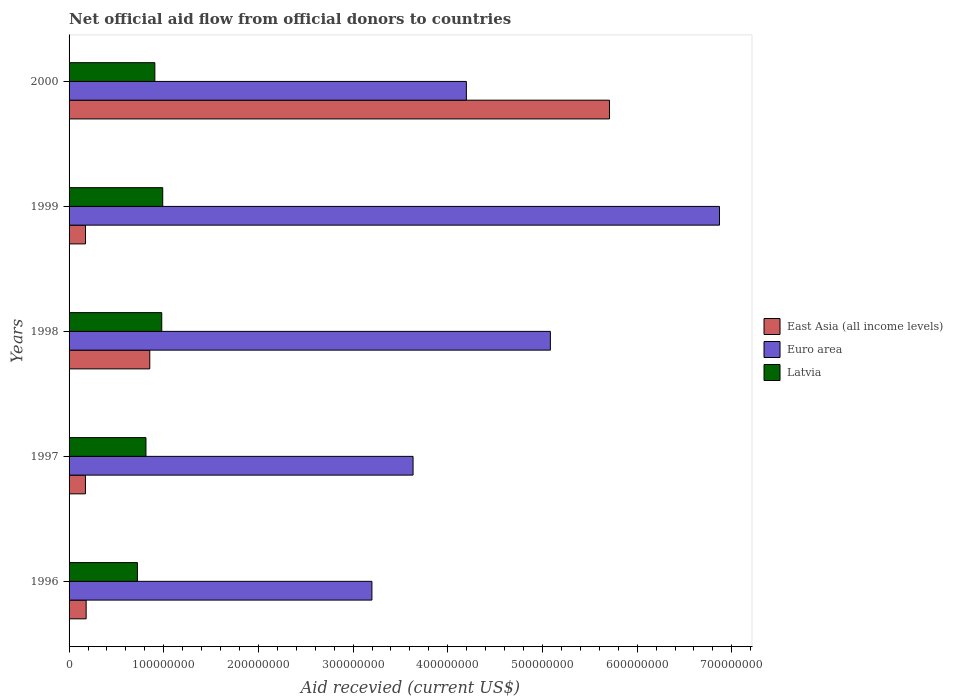Are the number of bars per tick equal to the number of legend labels?
Ensure brevity in your answer.  Yes. What is the label of the 5th group of bars from the top?
Your response must be concise. 1996. In how many cases, is the number of bars for a given year not equal to the number of legend labels?
Ensure brevity in your answer.  0. What is the total aid received in Latvia in 1996?
Your answer should be very brief. 7.22e+07. Across all years, what is the maximum total aid received in Latvia?
Keep it short and to the point. 9.89e+07. Across all years, what is the minimum total aid received in East Asia (all income levels)?
Give a very brief answer. 1.73e+07. In which year was the total aid received in Euro area minimum?
Your answer should be very brief. 1996. What is the total total aid received in Latvia in the graph?
Ensure brevity in your answer.  4.41e+08. What is the difference between the total aid received in Euro area in 1997 and that in 1998?
Your answer should be compact. -1.45e+08. What is the difference between the total aid received in Euro area in 1998 and the total aid received in East Asia (all income levels) in 1999?
Provide a succinct answer. 4.91e+08. What is the average total aid received in Latvia per year?
Offer a very short reply. 8.82e+07. In the year 1999, what is the difference between the total aid received in East Asia (all income levels) and total aid received in Latvia?
Your answer should be compact. -8.16e+07. In how many years, is the total aid received in Euro area greater than 640000000 US$?
Your answer should be very brief. 1. What is the ratio of the total aid received in Euro area in 1998 to that in 1999?
Offer a very short reply. 0.74. Is the total aid received in Euro area in 1996 less than that in 2000?
Provide a succinct answer. Yes. Is the difference between the total aid received in East Asia (all income levels) in 1999 and 2000 greater than the difference between the total aid received in Latvia in 1999 and 2000?
Provide a succinct answer. No. What is the difference between the highest and the second highest total aid received in East Asia (all income levels)?
Provide a succinct answer. 4.86e+08. What is the difference between the highest and the lowest total aid received in East Asia (all income levels)?
Your response must be concise. 5.54e+08. In how many years, is the total aid received in East Asia (all income levels) greater than the average total aid received in East Asia (all income levels) taken over all years?
Ensure brevity in your answer.  1. What does the 2nd bar from the bottom in 2000 represents?
Give a very brief answer. Euro area. Is it the case that in every year, the sum of the total aid received in East Asia (all income levels) and total aid received in Latvia is greater than the total aid received in Euro area?
Your answer should be very brief. No. Are all the bars in the graph horizontal?
Provide a short and direct response. Yes. How many years are there in the graph?
Your answer should be compact. 5. Does the graph contain any zero values?
Ensure brevity in your answer.  No. Where does the legend appear in the graph?
Offer a very short reply. Center right. How many legend labels are there?
Ensure brevity in your answer.  3. What is the title of the graph?
Offer a very short reply. Net official aid flow from official donors to countries. Does "Bosnia and Herzegovina" appear as one of the legend labels in the graph?
Your response must be concise. No. What is the label or title of the X-axis?
Provide a succinct answer. Aid recevied (current US$). What is the label or title of the Y-axis?
Provide a succinct answer. Years. What is the Aid recevied (current US$) in East Asia (all income levels) in 1996?
Your answer should be very brief. 1.80e+07. What is the Aid recevied (current US$) of Euro area in 1996?
Your response must be concise. 3.20e+08. What is the Aid recevied (current US$) of Latvia in 1996?
Your answer should be compact. 7.22e+07. What is the Aid recevied (current US$) of East Asia (all income levels) in 1997?
Provide a short and direct response. 1.73e+07. What is the Aid recevied (current US$) of Euro area in 1997?
Provide a short and direct response. 3.63e+08. What is the Aid recevied (current US$) of Latvia in 1997?
Provide a short and direct response. 8.12e+07. What is the Aid recevied (current US$) of East Asia (all income levels) in 1998?
Offer a very short reply. 8.52e+07. What is the Aid recevied (current US$) in Euro area in 1998?
Keep it short and to the point. 5.08e+08. What is the Aid recevied (current US$) in Latvia in 1998?
Provide a succinct answer. 9.79e+07. What is the Aid recevied (current US$) in East Asia (all income levels) in 1999?
Give a very brief answer. 1.74e+07. What is the Aid recevied (current US$) in Euro area in 1999?
Ensure brevity in your answer.  6.87e+08. What is the Aid recevied (current US$) of Latvia in 1999?
Offer a terse response. 9.89e+07. What is the Aid recevied (current US$) in East Asia (all income levels) in 2000?
Your answer should be compact. 5.71e+08. What is the Aid recevied (current US$) of Euro area in 2000?
Your answer should be compact. 4.20e+08. What is the Aid recevied (current US$) of Latvia in 2000?
Provide a short and direct response. 9.06e+07. Across all years, what is the maximum Aid recevied (current US$) in East Asia (all income levels)?
Your response must be concise. 5.71e+08. Across all years, what is the maximum Aid recevied (current US$) of Euro area?
Your answer should be very brief. 6.87e+08. Across all years, what is the maximum Aid recevied (current US$) of Latvia?
Keep it short and to the point. 9.89e+07. Across all years, what is the minimum Aid recevied (current US$) of East Asia (all income levels)?
Your answer should be compact. 1.73e+07. Across all years, what is the minimum Aid recevied (current US$) in Euro area?
Offer a terse response. 3.20e+08. Across all years, what is the minimum Aid recevied (current US$) of Latvia?
Offer a terse response. 7.22e+07. What is the total Aid recevied (current US$) of East Asia (all income levels) in the graph?
Provide a short and direct response. 7.09e+08. What is the total Aid recevied (current US$) of Euro area in the graph?
Make the answer very short. 2.30e+09. What is the total Aid recevied (current US$) in Latvia in the graph?
Provide a short and direct response. 4.41e+08. What is the difference between the Aid recevied (current US$) of East Asia (all income levels) in 1996 and that in 1997?
Keep it short and to the point. 7.60e+05. What is the difference between the Aid recevied (current US$) in Euro area in 1996 and that in 1997?
Offer a terse response. -4.35e+07. What is the difference between the Aid recevied (current US$) of Latvia in 1996 and that in 1997?
Your answer should be compact. -9.01e+06. What is the difference between the Aid recevied (current US$) in East Asia (all income levels) in 1996 and that in 1998?
Ensure brevity in your answer.  -6.72e+07. What is the difference between the Aid recevied (current US$) of Euro area in 1996 and that in 1998?
Offer a very short reply. -1.88e+08. What is the difference between the Aid recevied (current US$) in Latvia in 1996 and that in 1998?
Make the answer very short. -2.57e+07. What is the difference between the Aid recevied (current US$) of East Asia (all income levels) in 1996 and that in 1999?
Make the answer very short. 7.00e+05. What is the difference between the Aid recevied (current US$) in Euro area in 1996 and that in 1999?
Provide a short and direct response. -3.67e+08. What is the difference between the Aid recevied (current US$) in Latvia in 1996 and that in 1999?
Your response must be concise. -2.67e+07. What is the difference between the Aid recevied (current US$) in East Asia (all income levels) in 1996 and that in 2000?
Offer a very short reply. -5.53e+08. What is the difference between the Aid recevied (current US$) of Euro area in 1996 and that in 2000?
Your response must be concise. -9.98e+07. What is the difference between the Aid recevied (current US$) of Latvia in 1996 and that in 2000?
Your answer should be compact. -1.84e+07. What is the difference between the Aid recevied (current US$) of East Asia (all income levels) in 1997 and that in 1998?
Your answer should be very brief. -6.80e+07. What is the difference between the Aid recevied (current US$) in Euro area in 1997 and that in 1998?
Make the answer very short. -1.45e+08. What is the difference between the Aid recevied (current US$) in Latvia in 1997 and that in 1998?
Your answer should be compact. -1.67e+07. What is the difference between the Aid recevied (current US$) of Euro area in 1997 and that in 1999?
Ensure brevity in your answer.  -3.24e+08. What is the difference between the Aid recevied (current US$) in Latvia in 1997 and that in 1999?
Your response must be concise. -1.77e+07. What is the difference between the Aid recevied (current US$) of East Asia (all income levels) in 1997 and that in 2000?
Make the answer very short. -5.54e+08. What is the difference between the Aid recevied (current US$) of Euro area in 1997 and that in 2000?
Your answer should be very brief. -5.63e+07. What is the difference between the Aid recevied (current US$) in Latvia in 1997 and that in 2000?
Your answer should be very brief. -9.39e+06. What is the difference between the Aid recevied (current US$) of East Asia (all income levels) in 1998 and that in 1999?
Offer a very short reply. 6.79e+07. What is the difference between the Aid recevied (current US$) of Euro area in 1998 and that in 1999?
Provide a succinct answer. -1.79e+08. What is the difference between the Aid recevied (current US$) in Latvia in 1998 and that in 1999?
Provide a short and direct response. -1.04e+06. What is the difference between the Aid recevied (current US$) in East Asia (all income levels) in 1998 and that in 2000?
Keep it short and to the point. -4.86e+08. What is the difference between the Aid recevied (current US$) of Euro area in 1998 and that in 2000?
Make the answer very short. 8.87e+07. What is the difference between the Aid recevied (current US$) in Latvia in 1998 and that in 2000?
Provide a short and direct response. 7.30e+06. What is the difference between the Aid recevied (current US$) in East Asia (all income levels) in 1999 and that in 2000?
Your answer should be compact. -5.53e+08. What is the difference between the Aid recevied (current US$) in Euro area in 1999 and that in 2000?
Offer a very short reply. 2.67e+08. What is the difference between the Aid recevied (current US$) in Latvia in 1999 and that in 2000?
Your answer should be compact. 8.34e+06. What is the difference between the Aid recevied (current US$) in East Asia (all income levels) in 1996 and the Aid recevied (current US$) in Euro area in 1997?
Provide a succinct answer. -3.45e+08. What is the difference between the Aid recevied (current US$) of East Asia (all income levels) in 1996 and the Aid recevied (current US$) of Latvia in 1997?
Offer a very short reply. -6.32e+07. What is the difference between the Aid recevied (current US$) in Euro area in 1996 and the Aid recevied (current US$) in Latvia in 1997?
Give a very brief answer. 2.39e+08. What is the difference between the Aid recevied (current US$) of East Asia (all income levels) in 1996 and the Aid recevied (current US$) of Euro area in 1998?
Your answer should be compact. -4.90e+08. What is the difference between the Aid recevied (current US$) in East Asia (all income levels) in 1996 and the Aid recevied (current US$) in Latvia in 1998?
Provide a short and direct response. -7.98e+07. What is the difference between the Aid recevied (current US$) in Euro area in 1996 and the Aid recevied (current US$) in Latvia in 1998?
Your answer should be compact. 2.22e+08. What is the difference between the Aid recevied (current US$) of East Asia (all income levels) in 1996 and the Aid recevied (current US$) of Euro area in 1999?
Your answer should be very brief. -6.69e+08. What is the difference between the Aid recevied (current US$) in East Asia (all income levels) in 1996 and the Aid recevied (current US$) in Latvia in 1999?
Make the answer very short. -8.09e+07. What is the difference between the Aid recevied (current US$) of Euro area in 1996 and the Aid recevied (current US$) of Latvia in 1999?
Ensure brevity in your answer.  2.21e+08. What is the difference between the Aid recevied (current US$) of East Asia (all income levels) in 1996 and the Aid recevied (current US$) of Euro area in 2000?
Offer a very short reply. -4.02e+08. What is the difference between the Aid recevied (current US$) of East Asia (all income levels) in 1996 and the Aid recevied (current US$) of Latvia in 2000?
Ensure brevity in your answer.  -7.25e+07. What is the difference between the Aid recevied (current US$) of Euro area in 1996 and the Aid recevied (current US$) of Latvia in 2000?
Offer a very short reply. 2.29e+08. What is the difference between the Aid recevied (current US$) of East Asia (all income levels) in 1997 and the Aid recevied (current US$) of Euro area in 1998?
Ensure brevity in your answer.  -4.91e+08. What is the difference between the Aid recevied (current US$) of East Asia (all income levels) in 1997 and the Aid recevied (current US$) of Latvia in 1998?
Provide a short and direct response. -8.06e+07. What is the difference between the Aid recevied (current US$) of Euro area in 1997 and the Aid recevied (current US$) of Latvia in 1998?
Your response must be concise. 2.65e+08. What is the difference between the Aid recevied (current US$) of East Asia (all income levels) in 1997 and the Aid recevied (current US$) of Euro area in 1999?
Keep it short and to the point. -6.70e+08. What is the difference between the Aid recevied (current US$) in East Asia (all income levels) in 1997 and the Aid recevied (current US$) in Latvia in 1999?
Your answer should be compact. -8.16e+07. What is the difference between the Aid recevied (current US$) in Euro area in 1997 and the Aid recevied (current US$) in Latvia in 1999?
Provide a short and direct response. 2.64e+08. What is the difference between the Aid recevied (current US$) in East Asia (all income levels) in 1997 and the Aid recevied (current US$) in Euro area in 2000?
Your answer should be very brief. -4.02e+08. What is the difference between the Aid recevied (current US$) of East Asia (all income levels) in 1997 and the Aid recevied (current US$) of Latvia in 2000?
Provide a short and direct response. -7.33e+07. What is the difference between the Aid recevied (current US$) of Euro area in 1997 and the Aid recevied (current US$) of Latvia in 2000?
Keep it short and to the point. 2.73e+08. What is the difference between the Aid recevied (current US$) in East Asia (all income levels) in 1998 and the Aid recevied (current US$) in Euro area in 1999?
Your response must be concise. -6.02e+08. What is the difference between the Aid recevied (current US$) of East Asia (all income levels) in 1998 and the Aid recevied (current US$) of Latvia in 1999?
Keep it short and to the point. -1.37e+07. What is the difference between the Aid recevied (current US$) in Euro area in 1998 and the Aid recevied (current US$) in Latvia in 1999?
Provide a short and direct response. 4.09e+08. What is the difference between the Aid recevied (current US$) in East Asia (all income levels) in 1998 and the Aid recevied (current US$) in Euro area in 2000?
Provide a short and direct response. -3.34e+08. What is the difference between the Aid recevied (current US$) in East Asia (all income levels) in 1998 and the Aid recevied (current US$) in Latvia in 2000?
Your answer should be compact. -5.34e+06. What is the difference between the Aid recevied (current US$) in Euro area in 1998 and the Aid recevied (current US$) in Latvia in 2000?
Give a very brief answer. 4.18e+08. What is the difference between the Aid recevied (current US$) in East Asia (all income levels) in 1999 and the Aid recevied (current US$) in Euro area in 2000?
Make the answer very short. -4.02e+08. What is the difference between the Aid recevied (current US$) in East Asia (all income levels) in 1999 and the Aid recevied (current US$) in Latvia in 2000?
Make the answer very short. -7.32e+07. What is the difference between the Aid recevied (current US$) of Euro area in 1999 and the Aid recevied (current US$) of Latvia in 2000?
Provide a short and direct response. 5.96e+08. What is the average Aid recevied (current US$) in East Asia (all income levels) per year?
Your answer should be compact. 1.42e+08. What is the average Aid recevied (current US$) of Euro area per year?
Your response must be concise. 4.60e+08. What is the average Aid recevied (current US$) of Latvia per year?
Provide a succinct answer. 8.82e+07. In the year 1996, what is the difference between the Aid recevied (current US$) in East Asia (all income levels) and Aid recevied (current US$) in Euro area?
Your response must be concise. -3.02e+08. In the year 1996, what is the difference between the Aid recevied (current US$) of East Asia (all income levels) and Aid recevied (current US$) of Latvia?
Your answer should be compact. -5.41e+07. In the year 1996, what is the difference between the Aid recevied (current US$) of Euro area and Aid recevied (current US$) of Latvia?
Keep it short and to the point. 2.48e+08. In the year 1997, what is the difference between the Aid recevied (current US$) of East Asia (all income levels) and Aid recevied (current US$) of Euro area?
Offer a terse response. -3.46e+08. In the year 1997, what is the difference between the Aid recevied (current US$) of East Asia (all income levels) and Aid recevied (current US$) of Latvia?
Ensure brevity in your answer.  -6.39e+07. In the year 1997, what is the difference between the Aid recevied (current US$) in Euro area and Aid recevied (current US$) in Latvia?
Your response must be concise. 2.82e+08. In the year 1998, what is the difference between the Aid recevied (current US$) of East Asia (all income levels) and Aid recevied (current US$) of Euro area?
Your answer should be compact. -4.23e+08. In the year 1998, what is the difference between the Aid recevied (current US$) in East Asia (all income levels) and Aid recevied (current US$) in Latvia?
Your answer should be very brief. -1.26e+07. In the year 1998, what is the difference between the Aid recevied (current US$) of Euro area and Aid recevied (current US$) of Latvia?
Make the answer very short. 4.10e+08. In the year 1999, what is the difference between the Aid recevied (current US$) in East Asia (all income levels) and Aid recevied (current US$) in Euro area?
Keep it short and to the point. -6.70e+08. In the year 1999, what is the difference between the Aid recevied (current US$) in East Asia (all income levels) and Aid recevied (current US$) in Latvia?
Your answer should be compact. -8.16e+07. In the year 1999, what is the difference between the Aid recevied (current US$) in Euro area and Aid recevied (current US$) in Latvia?
Your answer should be very brief. 5.88e+08. In the year 2000, what is the difference between the Aid recevied (current US$) of East Asia (all income levels) and Aid recevied (current US$) of Euro area?
Keep it short and to the point. 1.51e+08. In the year 2000, what is the difference between the Aid recevied (current US$) of East Asia (all income levels) and Aid recevied (current US$) of Latvia?
Offer a very short reply. 4.80e+08. In the year 2000, what is the difference between the Aid recevied (current US$) in Euro area and Aid recevied (current US$) in Latvia?
Make the answer very short. 3.29e+08. What is the ratio of the Aid recevied (current US$) of East Asia (all income levels) in 1996 to that in 1997?
Offer a terse response. 1.04. What is the ratio of the Aid recevied (current US$) of Euro area in 1996 to that in 1997?
Keep it short and to the point. 0.88. What is the ratio of the Aid recevied (current US$) of Latvia in 1996 to that in 1997?
Offer a terse response. 0.89. What is the ratio of the Aid recevied (current US$) in East Asia (all income levels) in 1996 to that in 1998?
Provide a succinct answer. 0.21. What is the ratio of the Aid recevied (current US$) of Euro area in 1996 to that in 1998?
Your answer should be very brief. 0.63. What is the ratio of the Aid recevied (current US$) of Latvia in 1996 to that in 1998?
Provide a short and direct response. 0.74. What is the ratio of the Aid recevied (current US$) in East Asia (all income levels) in 1996 to that in 1999?
Offer a very short reply. 1.04. What is the ratio of the Aid recevied (current US$) in Euro area in 1996 to that in 1999?
Provide a succinct answer. 0.47. What is the ratio of the Aid recevied (current US$) of Latvia in 1996 to that in 1999?
Provide a short and direct response. 0.73. What is the ratio of the Aid recevied (current US$) in East Asia (all income levels) in 1996 to that in 2000?
Keep it short and to the point. 0.03. What is the ratio of the Aid recevied (current US$) of Euro area in 1996 to that in 2000?
Your answer should be compact. 0.76. What is the ratio of the Aid recevied (current US$) in Latvia in 1996 to that in 2000?
Give a very brief answer. 0.8. What is the ratio of the Aid recevied (current US$) in East Asia (all income levels) in 1997 to that in 1998?
Your response must be concise. 0.2. What is the ratio of the Aid recevied (current US$) in Euro area in 1997 to that in 1998?
Your response must be concise. 0.71. What is the ratio of the Aid recevied (current US$) in Latvia in 1997 to that in 1998?
Make the answer very short. 0.83. What is the ratio of the Aid recevied (current US$) of Euro area in 1997 to that in 1999?
Offer a very short reply. 0.53. What is the ratio of the Aid recevied (current US$) of Latvia in 1997 to that in 1999?
Keep it short and to the point. 0.82. What is the ratio of the Aid recevied (current US$) of East Asia (all income levels) in 1997 to that in 2000?
Make the answer very short. 0.03. What is the ratio of the Aid recevied (current US$) of Euro area in 1997 to that in 2000?
Provide a succinct answer. 0.87. What is the ratio of the Aid recevied (current US$) of Latvia in 1997 to that in 2000?
Your response must be concise. 0.9. What is the ratio of the Aid recevied (current US$) in East Asia (all income levels) in 1998 to that in 1999?
Your response must be concise. 4.91. What is the ratio of the Aid recevied (current US$) of Euro area in 1998 to that in 1999?
Offer a terse response. 0.74. What is the ratio of the Aid recevied (current US$) in Latvia in 1998 to that in 1999?
Your response must be concise. 0.99. What is the ratio of the Aid recevied (current US$) in East Asia (all income levels) in 1998 to that in 2000?
Make the answer very short. 0.15. What is the ratio of the Aid recevied (current US$) in Euro area in 1998 to that in 2000?
Offer a terse response. 1.21. What is the ratio of the Aid recevied (current US$) of Latvia in 1998 to that in 2000?
Provide a succinct answer. 1.08. What is the ratio of the Aid recevied (current US$) of East Asia (all income levels) in 1999 to that in 2000?
Provide a succinct answer. 0.03. What is the ratio of the Aid recevied (current US$) in Euro area in 1999 to that in 2000?
Offer a very short reply. 1.64. What is the ratio of the Aid recevied (current US$) of Latvia in 1999 to that in 2000?
Keep it short and to the point. 1.09. What is the difference between the highest and the second highest Aid recevied (current US$) in East Asia (all income levels)?
Provide a short and direct response. 4.86e+08. What is the difference between the highest and the second highest Aid recevied (current US$) in Euro area?
Make the answer very short. 1.79e+08. What is the difference between the highest and the second highest Aid recevied (current US$) of Latvia?
Make the answer very short. 1.04e+06. What is the difference between the highest and the lowest Aid recevied (current US$) of East Asia (all income levels)?
Give a very brief answer. 5.54e+08. What is the difference between the highest and the lowest Aid recevied (current US$) in Euro area?
Your answer should be compact. 3.67e+08. What is the difference between the highest and the lowest Aid recevied (current US$) in Latvia?
Make the answer very short. 2.67e+07. 